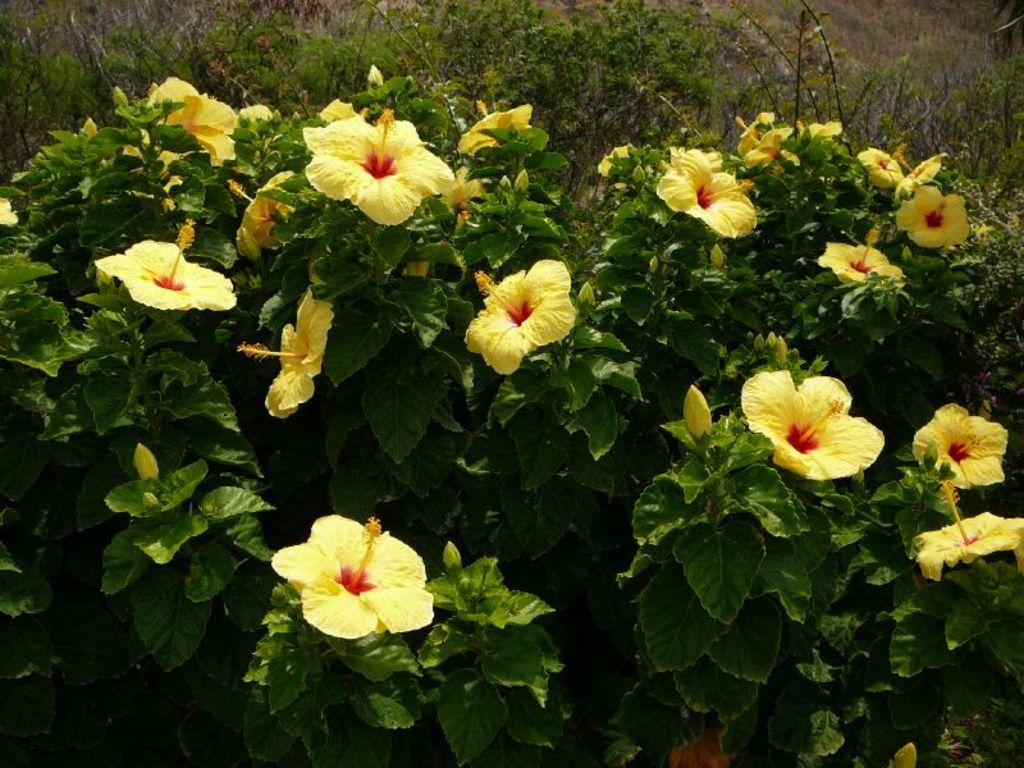What is located in the center of the image? There are plants in the center of the image. What type of plants can be seen in the image? There are flowers in the image. What color are the flowers? The flowers are yellow in color. What type of note can be seen on the page in the image? There is no page or note present in the image; it only features plants and flowers. 